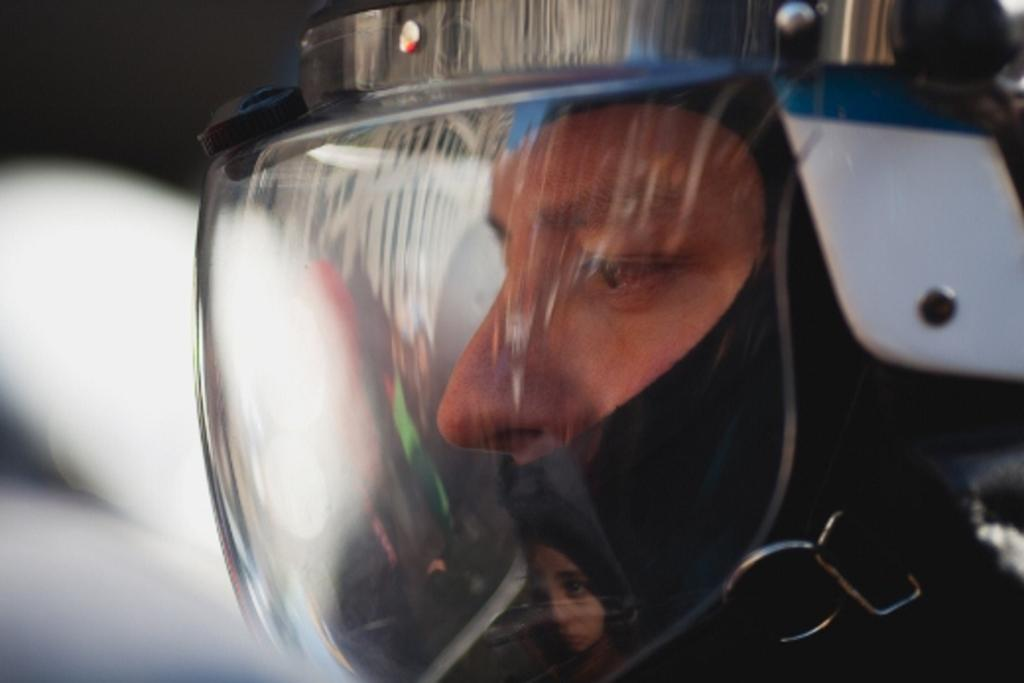What is present in the image? There is a person in the image. What is the person wearing? The person is wearing a helmet. What type of finger can be seen in the image? There is no finger visible in the image; only a person wearing a helmet is present. 